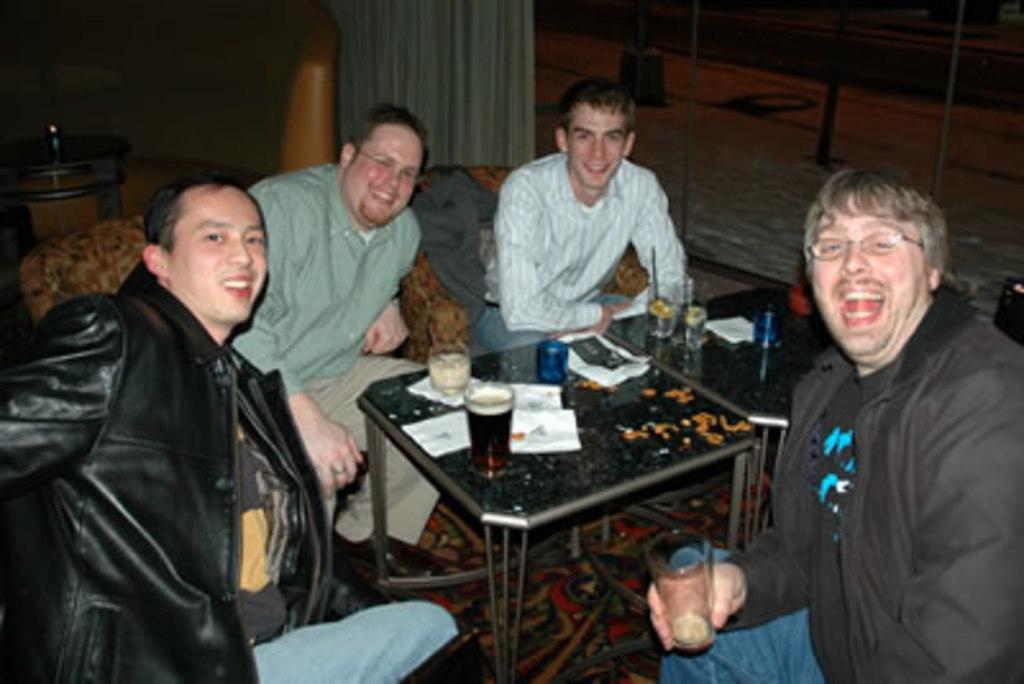Can you describe this image briefly? In the picture we can see a four people are sitting on the chairs near the table on the table we can find a cup, tissues, and some snacks, In the background we can find a curtain which is white in color and a poles on floor. 